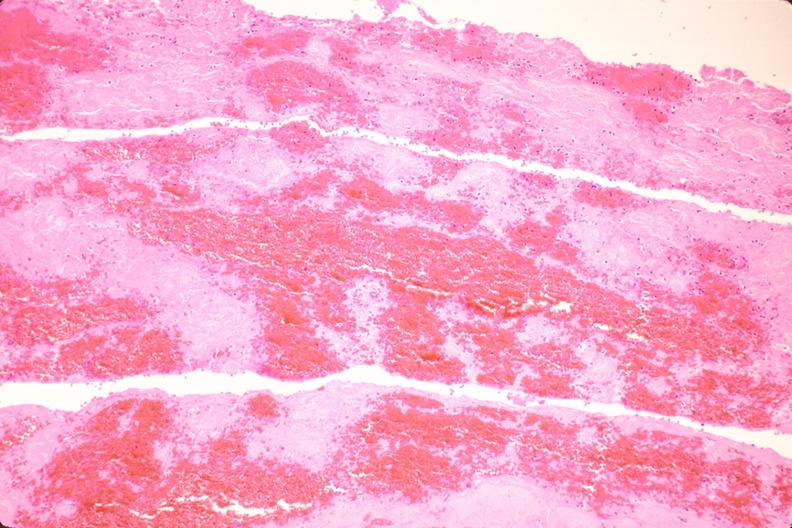does this image show thromboembolus from leg veins in pulmonary artery?
Answer the question using a single word or phrase. Yes 